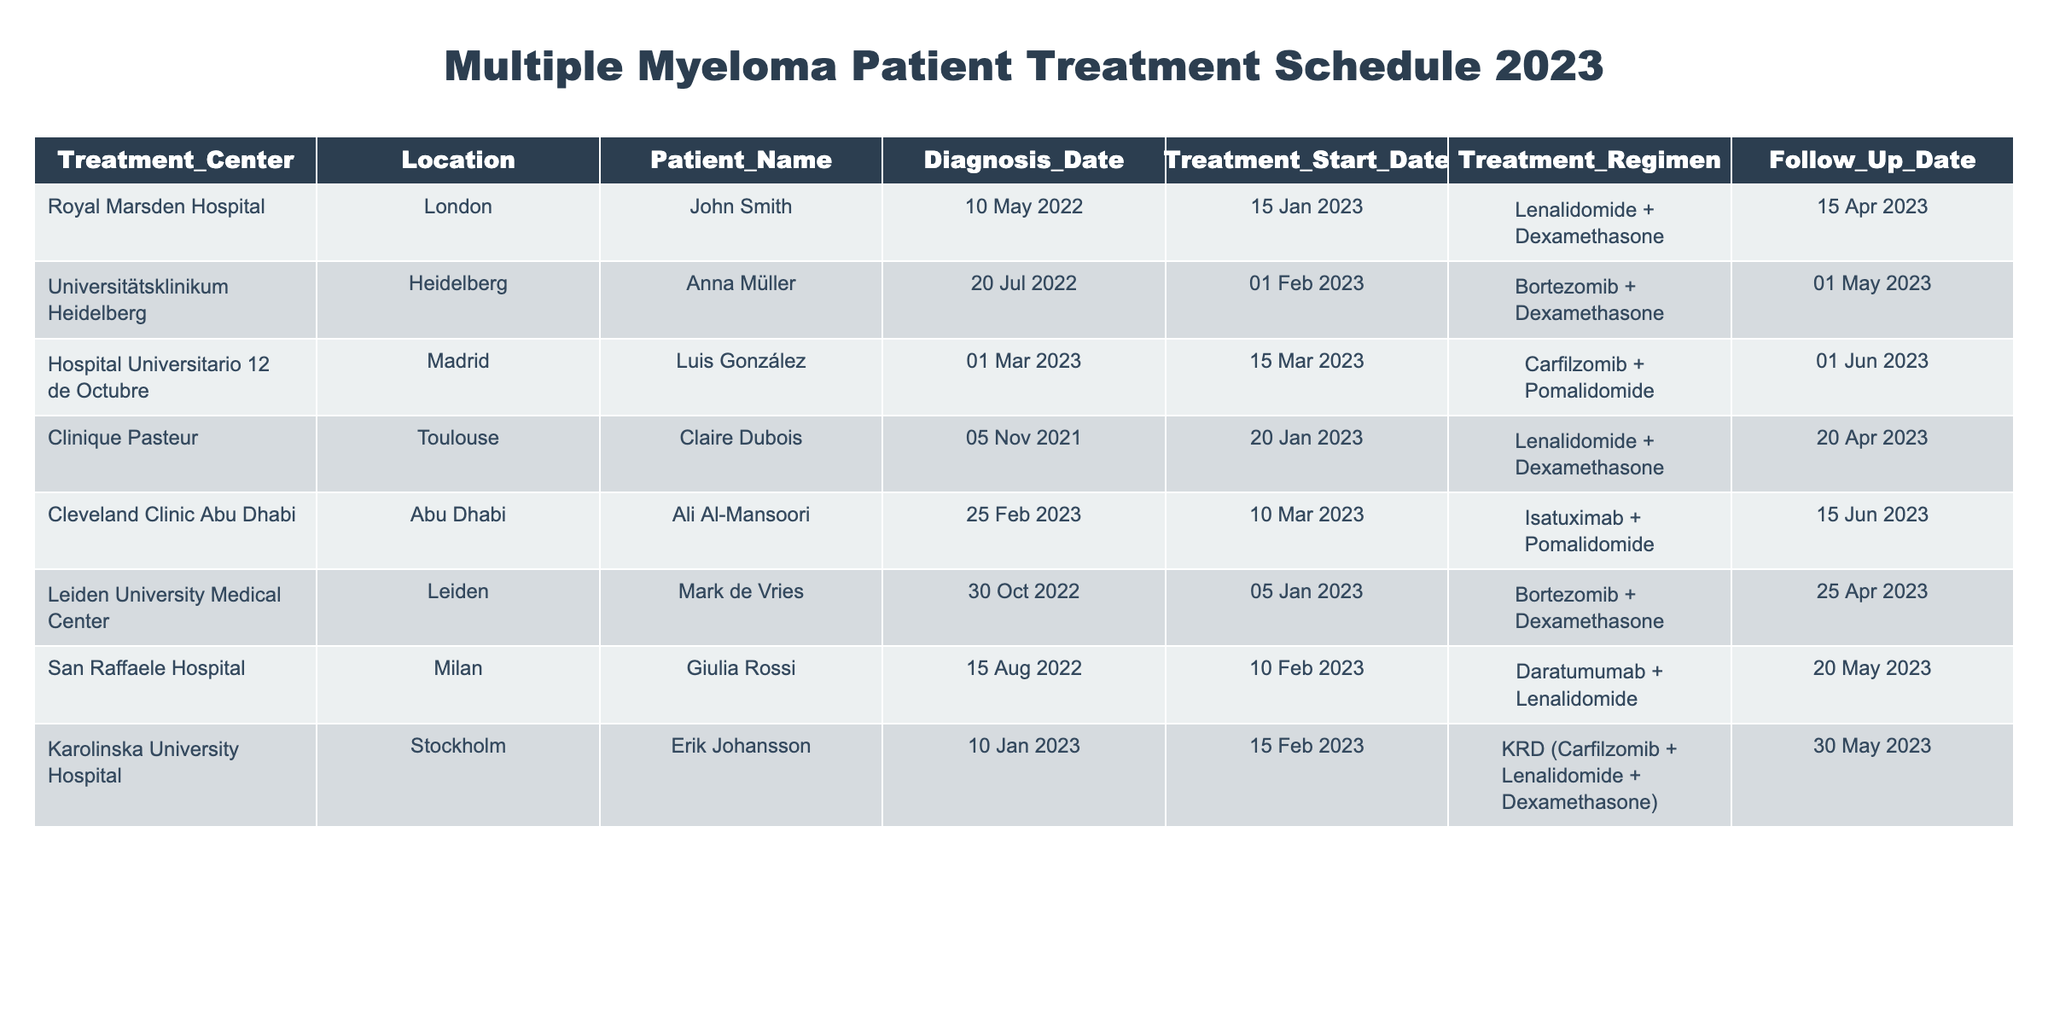What is the treatment regimen for Luis González? From the table, I can look at the row corresponding to Luis González under the Treatment_Regimen column. His treatment is listed as "Carfilzomib + Pomalidomide."
Answer: Carfilzomib + Pomalidomide When did Claire Dubois's treatment start? To find Claire Dubois's treatment start date, I check her row in the Treatment_Start_Date column. It shows "20 Jan 2023."
Answer: 20 Jan 2023 How many patients had their treatment start dates in February 2023? I review the Treatment_Start_Date column and look for dates in February 2023. The patients are Anna Müller (1 Feb), Giulia Rossi (10 Feb), and Erik Johansson (15 Feb). Therefore, there are three patients.
Answer: 3 Is the follow-up date for Ali Al-Mansoori after 1 June 2023? I look at the Follow_Up_Date for Ali Al-Mansoori which is "15 Jun 2023." This date is indeed after 1 June 2023.
Answer: Yes Which patient started treatment on the earliest date? I compare all the Treatment_Start_Date values. The earliest date found is associated with John Smith, whose treatment started on "15 Jan 2023." Thus, he started treatment the earliest.
Answer: John Smith 